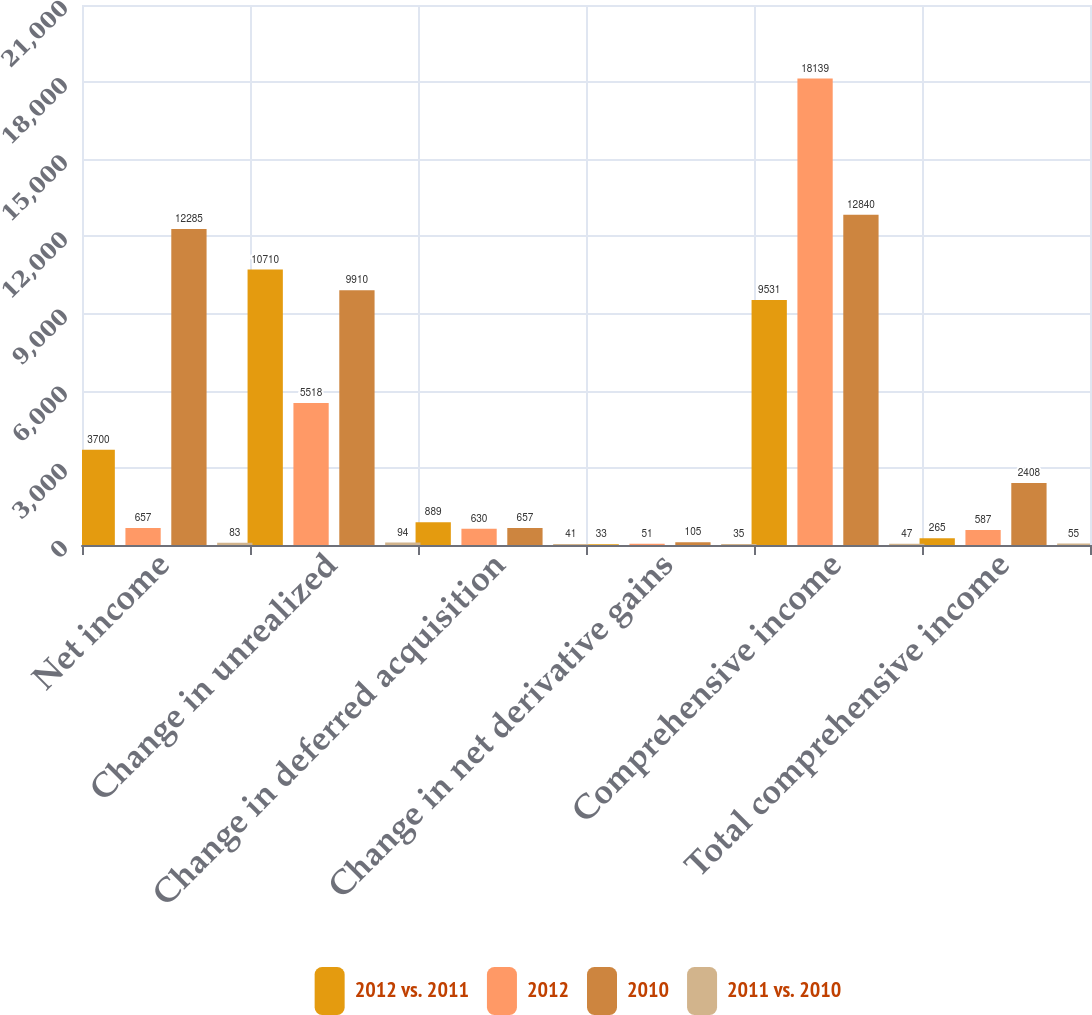Convert chart. <chart><loc_0><loc_0><loc_500><loc_500><stacked_bar_chart><ecel><fcel>Net income<fcel>Change in unrealized<fcel>Change in deferred acquisition<fcel>Change in net derivative gains<fcel>Comprehensive income<fcel>Total comprehensive income<nl><fcel>2012 vs. 2011<fcel>3700<fcel>10710<fcel>889<fcel>33<fcel>9531<fcel>265<nl><fcel>2012<fcel>657<fcel>5518<fcel>630<fcel>51<fcel>18139<fcel>587<nl><fcel>2010<fcel>12285<fcel>9910<fcel>657<fcel>105<fcel>12840<fcel>2408<nl><fcel>2011 vs. 2010<fcel>83<fcel>94<fcel>41<fcel>35<fcel>47<fcel>55<nl></chart> 